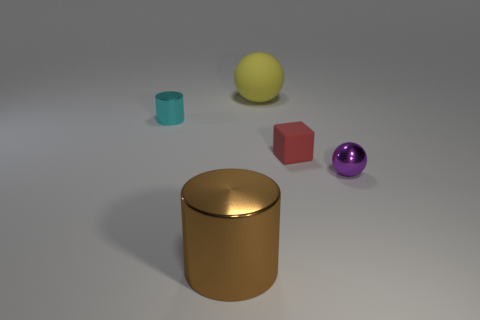Add 2 big cylinders. How many objects exist? 7 Subtract all cylinders. How many objects are left? 3 Subtract all big brown metallic things. Subtract all small cylinders. How many objects are left? 3 Add 5 yellow balls. How many yellow balls are left? 6 Add 2 blue metal balls. How many blue metal balls exist? 2 Subtract 0 green spheres. How many objects are left? 5 